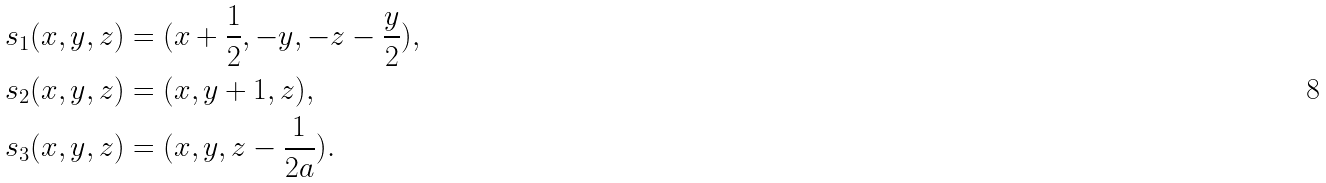<formula> <loc_0><loc_0><loc_500><loc_500>s _ { 1 } ( x , y , z ) & = ( x + \frac { 1 } { 2 } , - y , - z - \frac { y } { 2 } ) , \\ s _ { 2 } ( x , y , z ) & = ( x , y + 1 , z ) , \\ s _ { 3 } ( x , y , z ) & = ( x , y , z - \frac { 1 } { 2 a } ) .</formula> 